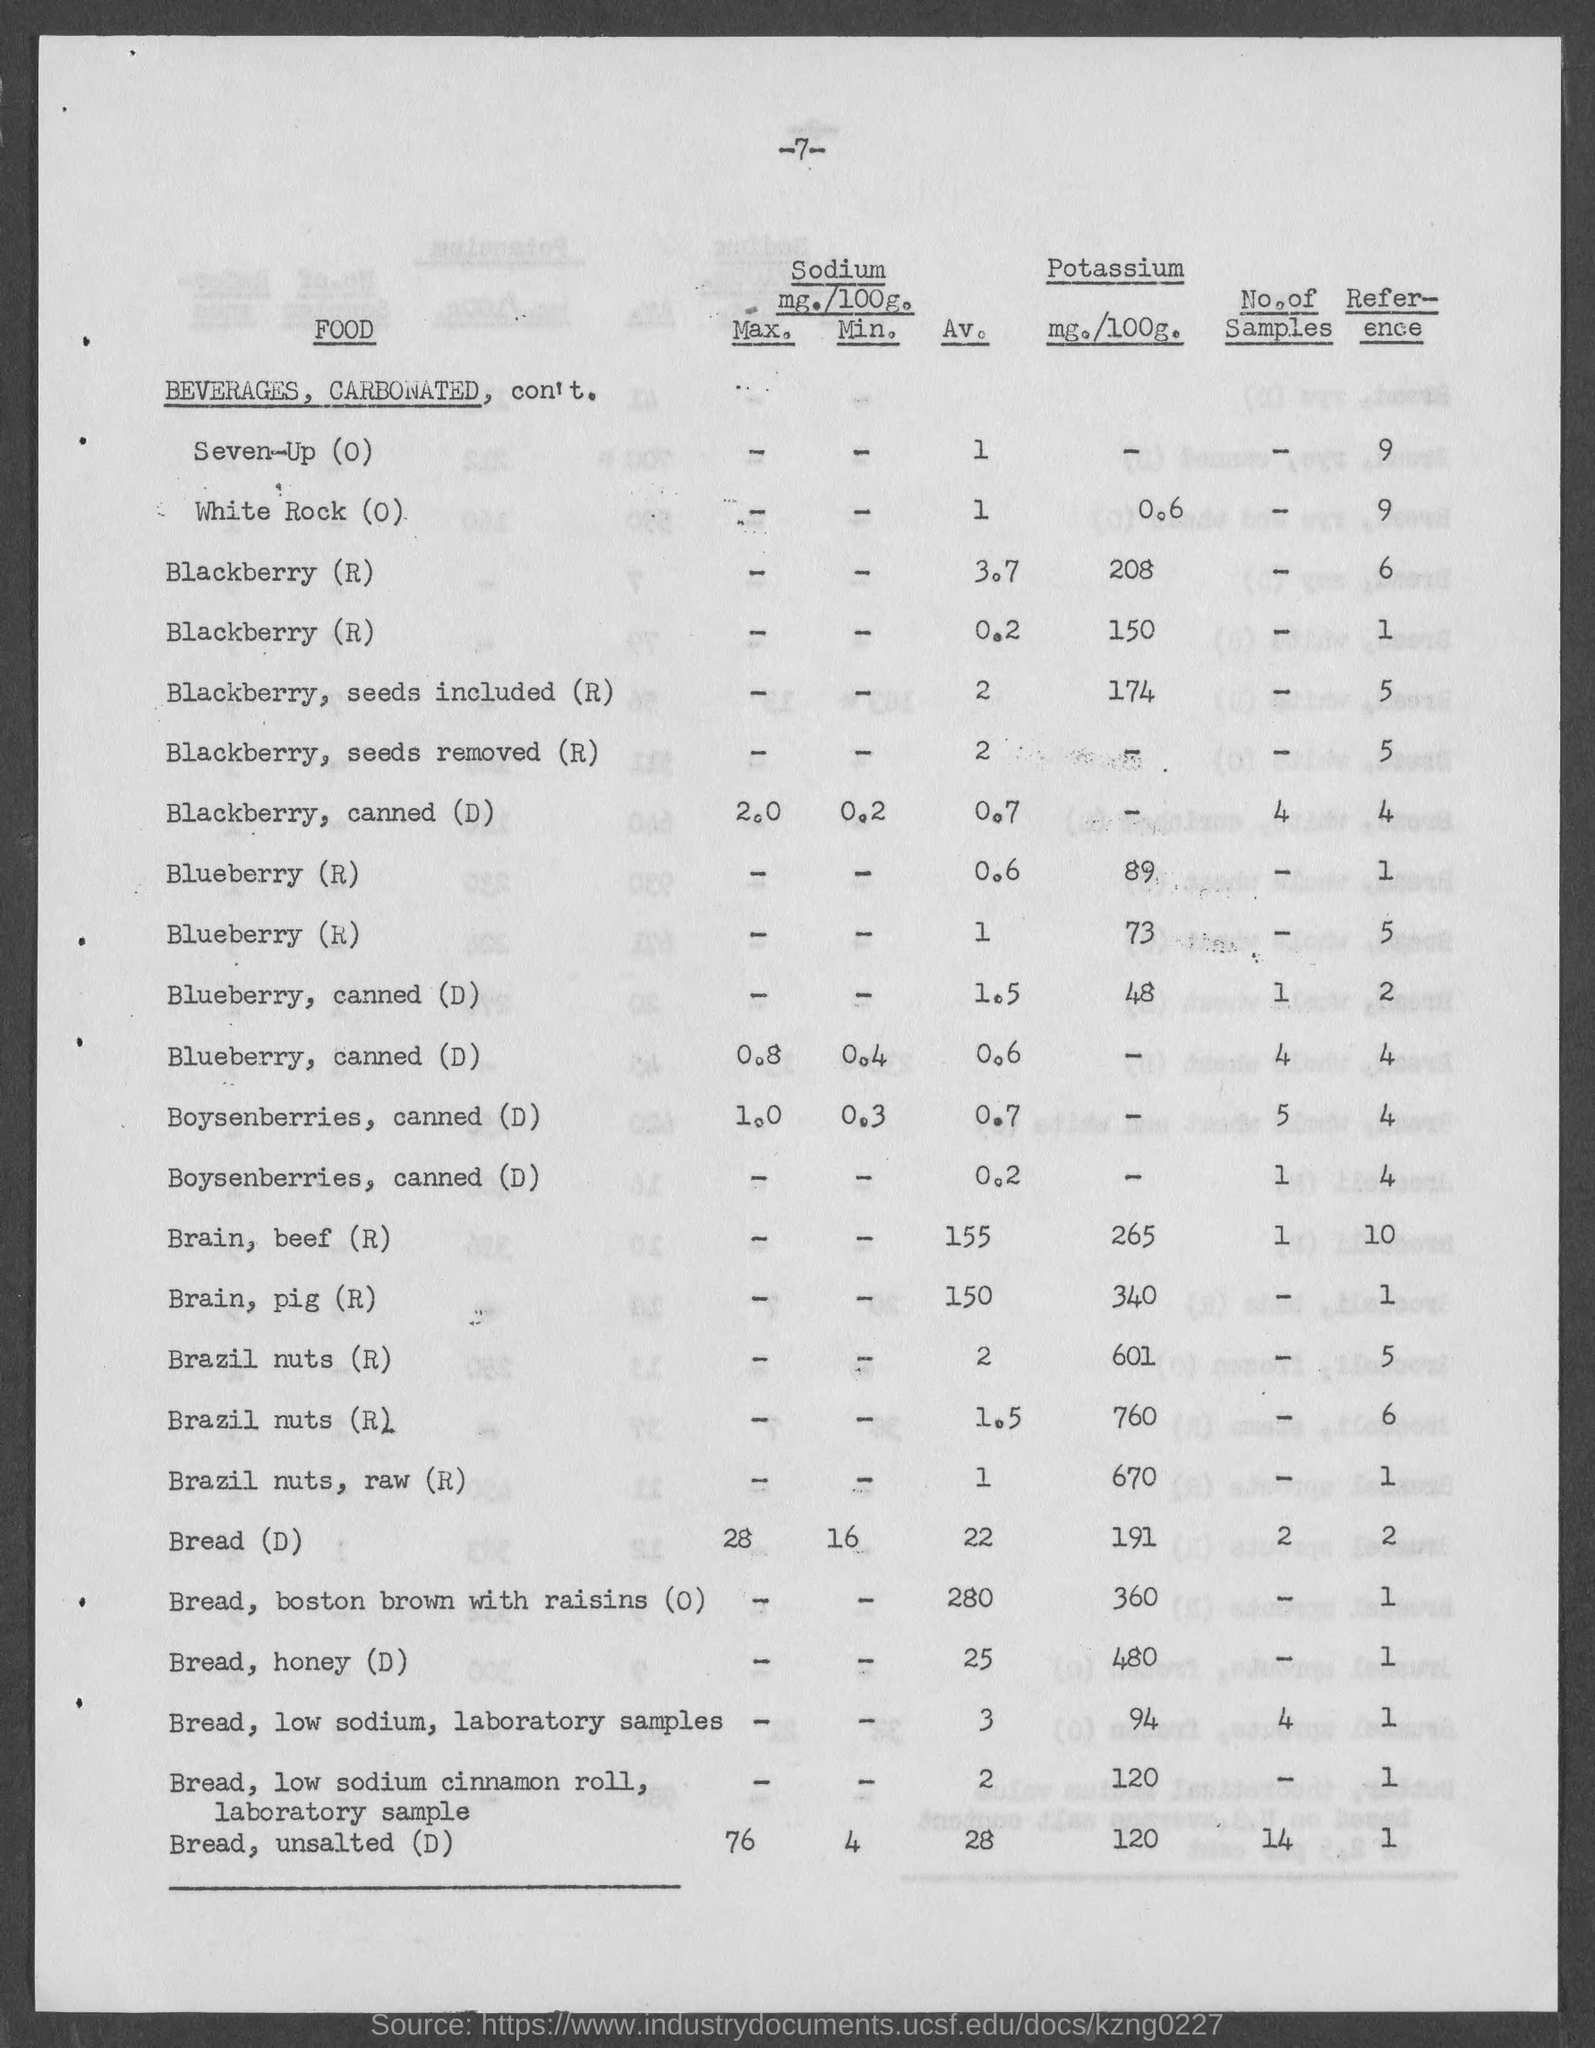Identify some key points in this picture. The amount of Potassium in 100 grams of Bread is 191 milligrams. The amount of potassium in 100 grams of brain from a pig is 340 milligrams. The amount of Potassium in 100 grams of bread with honey is 480 milligrams. The amount of potassium in 100 grams of bread, Boston brown with raisins is 360 milligrams. The amount of Potassium in white rock is 0.6 milligrams per 100 grams. 